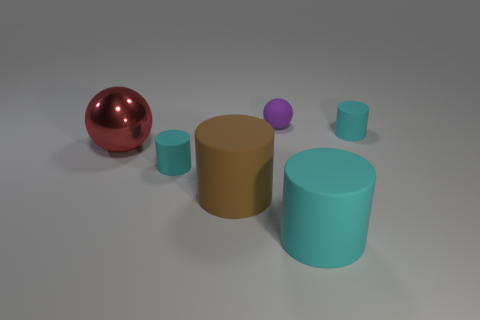Subtract all large brown matte cylinders. How many cylinders are left? 3 Subtract 2 spheres. How many spheres are left? 0 Subtract all brown cylinders. How many cylinders are left? 3 Add 3 purple metallic spheres. How many objects exist? 9 Subtract all cylinders. How many objects are left? 2 Subtract all red balls. How many red cylinders are left? 0 Add 1 big brown rubber cylinders. How many big brown rubber cylinders exist? 2 Subtract 0 green spheres. How many objects are left? 6 Subtract all gray cylinders. Subtract all blue spheres. How many cylinders are left? 4 Subtract all large brown shiny blocks. Subtract all big cyan rubber things. How many objects are left? 5 